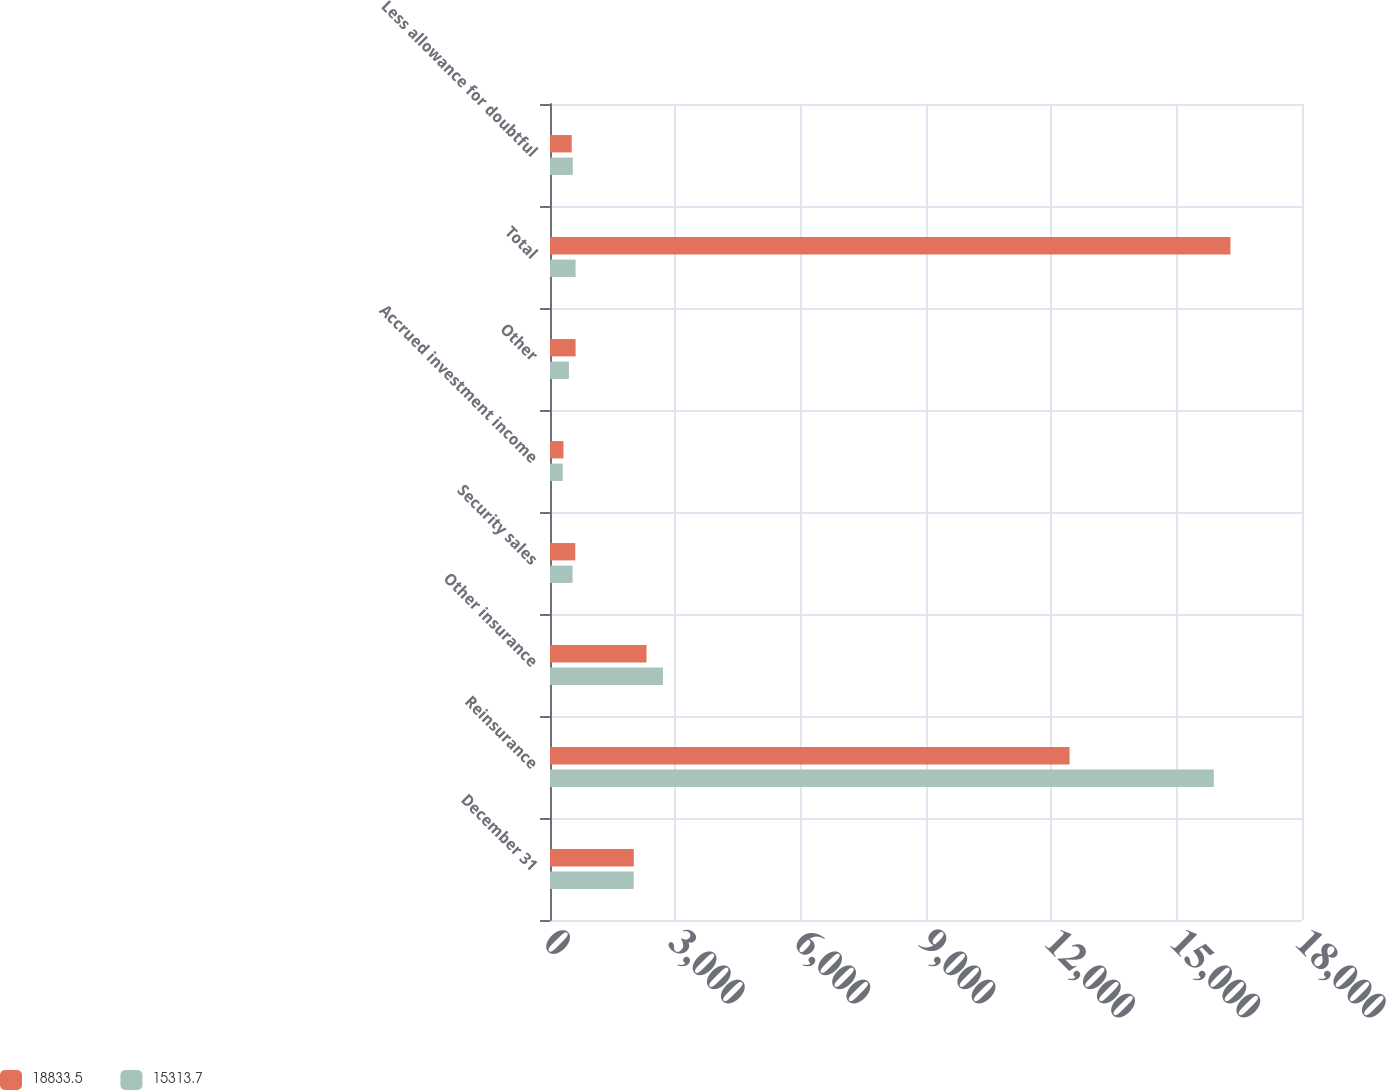Convert chart. <chart><loc_0><loc_0><loc_500><loc_500><stacked_bar_chart><ecel><fcel>December 31<fcel>Reinsurance<fcel>Other insurance<fcel>Security sales<fcel>Accrued investment income<fcel>Other<fcel>Total<fcel>Less allowance for doubtful<nl><fcel>18833.5<fcel>2005<fcel>12436.7<fcel>2310.6<fcel>604.9<fcel>322.2<fcel>612.6<fcel>16287<fcel>519.3<nl><fcel>15313.7<fcel>2004<fcel>15888<fcel>2704.5<fcel>540.3<fcel>304.9<fcel>453<fcel>612.6<fcel>546.3<nl></chart> 